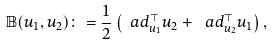<formula> <loc_0><loc_0><loc_500><loc_500>\mathbb { B } ( u _ { 1 } , u _ { 2 } ) \colon = \frac { 1 } { 2 } \left ( \ a d _ { u _ { 1 } } ^ { \top } u _ { 2 } + \ a d _ { u _ { 2 } } ^ { \top } u _ { 1 } \right ) ,</formula> 